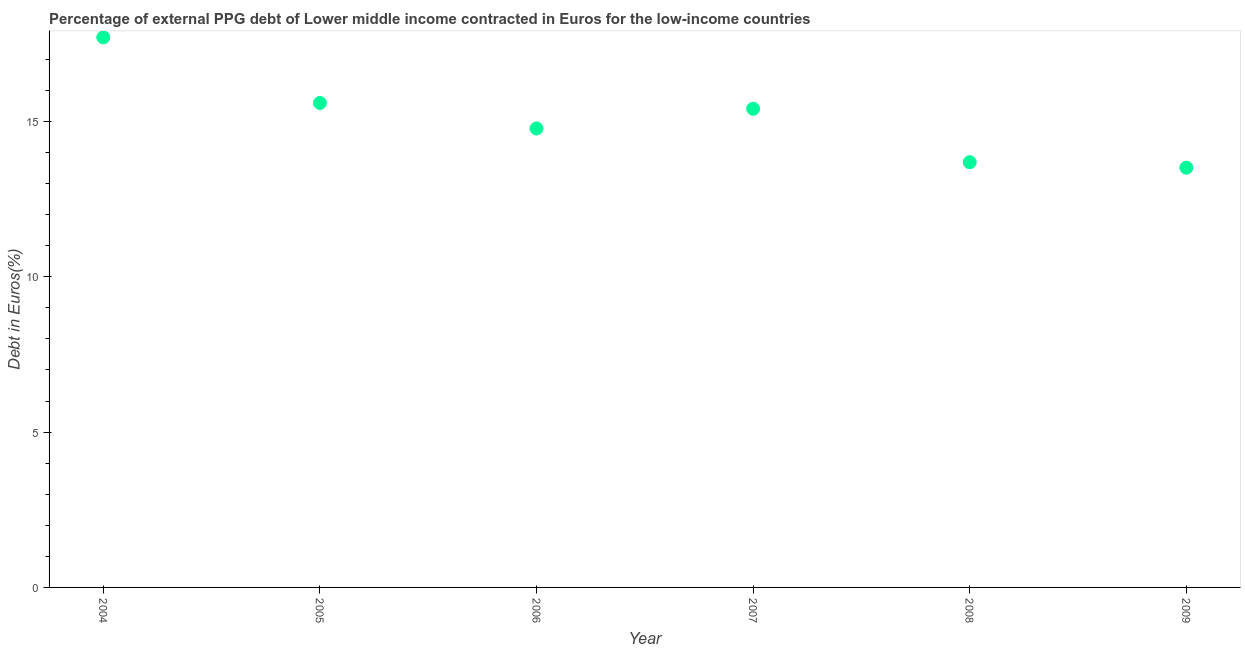What is the currency composition of ppg debt in 2008?
Your answer should be compact. 13.69. Across all years, what is the maximum currency composition of ppg debt?
Provide a short and direct response. 17.71. Across all years, what is the minimum currency composition of ppg debt?
Make the answer very short. 13.51. In which year was the currency composition of ppg debt minimum?
Your answer should be compact. 2009. What is the sum of the currency composition of ppg debt?
Offer a very short reply. 90.68. What is the difference between the currency composition of ppg debt in 2004 and 2009?
Your response must be concise. 4.19. What is the average currency composition of ppg debt per year?
Ensure brevity in your answer.  15.11. What is the median currency composition of ppg debt?
Your answer should be very brief. 15.09. In how many years, is the currency composition of ppg debt greater than 10 %?
Your response must be concise. 6. Do a majority of the years between 2009 and 2004 (inclusive) have currency composition of ppg debt greater than 9 %?
Your answer should be compact. Yes. What is the ratio of the currency composition of ppg debt in 2005 to that in 2009?
Offer a terse response. 1.15. What is the difference between the highest and the second highest currency composition of ppg debt?
Provide a short and direct response. 2.11. What is the difference between the highest and the lowest currency composition of ppg debt?
Provide a succinct answer. 4.19. In how many years, is the currency composition of ppg debt greater than the average currency composition of ppg debt taken over all years?
Your response must be concise. 3. Does the currency composition of ppg debt monotonically increase over the years?
Provide a succinct answer. No. What is the difference between two consecutive major ticks on the Y-axis?
Make the answer very short. 5. What is the title of the graph?
Give a very brief answer. Percentage of external PPG debt of Lower middle income contracted in Euros for the low-income countries. What is the label or title of the X-axis?
Keep it short and to the point. Year. What is the label or title of the Y-axis?
Offer a terse response. Debt in Euros(%). What is the Debt in Euros(%) in 2004?
Give a very brief answer. 17.71. What is the Debt in Euros(%) in 2005?
Make the answer very short. 15.6. What is the Debt in Euros(%) in 2006?
Keep it short and to the point. 14.77. What is the Debt in Euros(%) in 2007?
Ensure brevity in your answer.  15.41. What is the Debt in Euros(%) in 2008?
Provide a succinct answer. 13.69. What is the Debt in Euros(%) in 2009?
Provide a succinct answer. 13.51. What is the difference between the Debt in Euros(%) in 2004 and 2005?
Offer a very short reply. 2.11. What is the difference between the Debt in Euros(%) in 2004 and 2006?
Provide a succinct answer. 2.93. What is the difference between the Debt in Euros(%) in 2004 and 2007?
Your response must be concise. 2.3. What is the difference between the Debt in Euros(%) in 2004 and 2008?
Your answer should be very brief. 4.02. What is the difference between the Debt in Euros(%) in 2004 and 2009?
Your answer should be compact. 4.19. What is the difference between the Debt in Euros(%) in 2005 and 2006?
Offer a very short reply. 0.82. What is the difference between the Debt in Euros(%) in 2005 and 2007?
Provide a succinct answer. 0.19. What is the difference between the Debt in Euros(%) in 2005 and 2008?
Your answer should be compact. 1.91. What is the difference between the Debt in Euros(%) in 2005 and 2009?
Offer a terse response. 2.08. What is the difference between the Debt in Euros(%) in 2006 and 2007?
Your answer should be compact. -0.64. What is the difference between the Debt in Euros(%) in 2006 and 2008?
Ensure brevity in your answer.  1.09. What is the difference between the Debt in Euros(%) in 2006 and 2009?
Your response must be concise. 1.26. What is the difference between the Debt in Euros(%) in 2007 and 2008?
Ensure brevity in your answer.  1.72. What is the difference between the Debt in Euros(%) in 2007 and 2009?
Ensure brevity in your answer.  1.9. What is the difference between the Debt in Euros(%) in 2008 and 2009?
Your answer should be very brief. 0.18. What is the ratio of the Debt in Euros(%) in 2004 to that in 2005?
Ensure brevity in your answer.  1.14. What is the ratio of the Debt in Euros(%) in 2004 to that in 2006?
Keep it short and to the point. 1.2. What is the ratio of the Debt in Euros(%) in 2004 to that in 2007?
Make the answer very short. 1.15. What is the ratio of the Debt in Euros(%) in 2004 to that in 2008?
Your answer should be very brief. 1.29. What is the ratio of the Debt in Euros(%) in 2004 to that in 2009?
Give a very brief answer. 1.31. What is the ratio of the Debt in Euros(%) in 2005 to that in 2006?
Keep it short and to the point. 1.06. What is the ratio of the Debt in Euros(%) in 2005 to that in 2007?
Your response must be concise. 1.01. What is the ratio of the Debt in Euros(%) in 2005 to that in 2008?
Provide a short and direct response. 1.14. What is the ratio of the Debt in Euros(%) in 2005 to that in 2009?
Keep it short and to the point. 1.15. What is the ratio of the Debt in Euros(%) in 2006 to that in 2007?
Provide a short and direct response. 0.96. What is the ratio of the Debt in Euros(%) in 2006 to that in 2008?
Provide a succinct answer. 1.08. What is the ratio of the Debt in Euros(%) in 2006 to that in 2009?
Ensure brevity in your answer.  1.09. What is the ratio of the Debt in Euros(%) in 2007 to that in 2008?
Your answer should be compact. 1.13. What is the ratio of the Debt in Euros(%) in 2007 to that in 2009?
Ensure brevity in your answer.  1.14. 